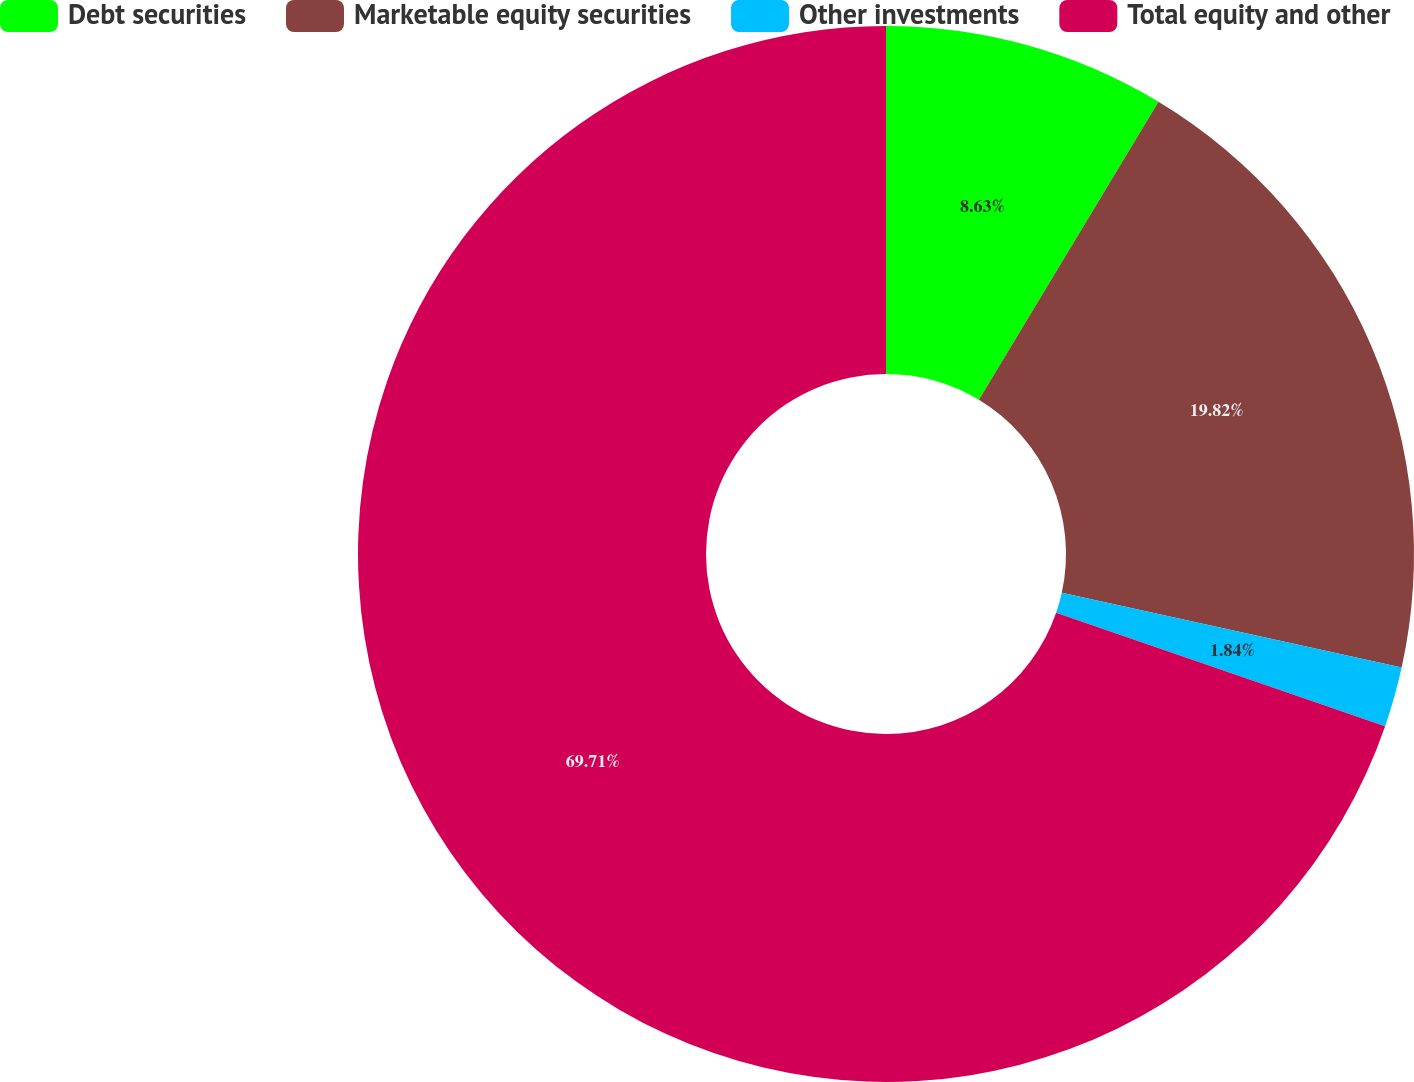Convert chart. <chart><loc_0><loc_0><loc_500><loc_500><pie_chart><fcel>Debt securities<fcel>Marketable equity securities<fcel>Other investments<fcel>Total equity and other<nl><fcel>8.63%<fcel>19.82%<fcel>1.84%<fcel>69.71%<nl></chart> 